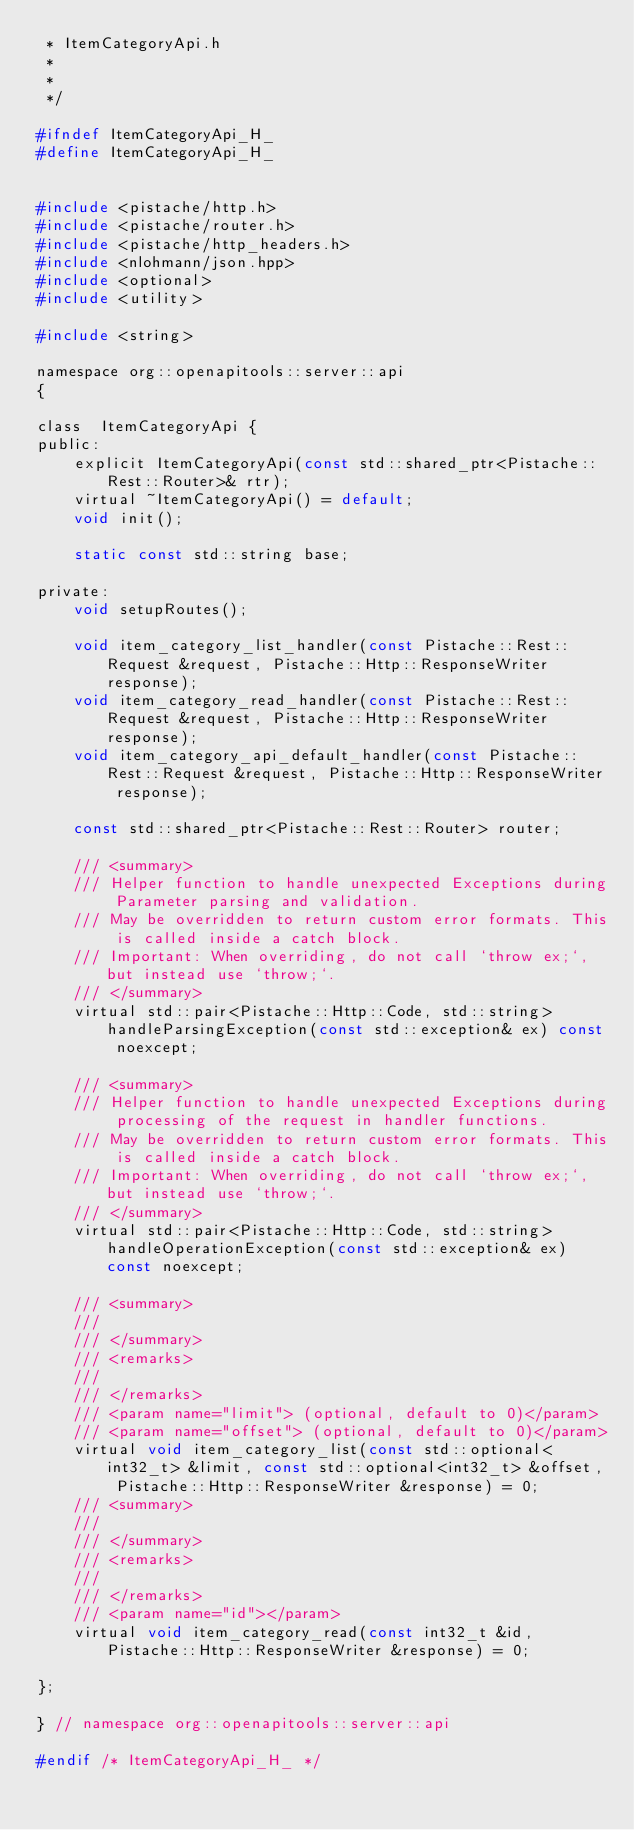<code> <loc_0><loc_0><loc_500><loc_500><_C_> * ItemCategoryApi.h
 *
 * 
 */

#ifndef ItemCategoryApi_H_
#define ItemCategoryApi_H_


#include <pistache/http.h>
#include <pistache/router.h>
#include <pistache/http_headers.h>
#include <nlohmann/json.hpp>
#include <optional>
#include <utility>

#include <string>

namespace org::openapitools::server::api
{

class  ItemCategoryApi {
public:
    explicit ItemCategoryApi(const std::shared_ptr<Pistache::Rest::Router>& rtr);
    virtual ~ItemCategoryApi() = default;
    void init();

    static const std::string base;

private:
    void setupRoutes();

    void item_category_list_handler(const Pistache::Rest::Request &request, Pistache::Http::ResponseWriter response);
    void item_category_read_handler(const Pistache::Rest::Request &request, Pistache::Http::ResponseWriter response);
    void item_category_api_default_handler(const Pistache::Rest::Request &request, Pistache::Http::ResponseWriter response);

    const std::shared_ptr<Pistache::Rest::Router> router;

    /// <summary>
    /// Helper function to handle unexpected Exceptions during Parameter parsing and validation.
    /// May be overridden to return custom error formats. This is called inside a catch block.
    /// Important: When overriding, do not call `throw ex;`, but instead use `throw;`.
    /// </summary>
    virtual std::pair<Pistache::Http::Code, std::string> handleParsingException(const std::exception& ex) const noexcept;

    /// <summary>
    /// Helper function to handle unexpected Exceptions during processing of the request in handler functions.
    /// May be overridden to return custom error formats. This is called inside a catch block.
    /// Important: When overriding, do not call `throw ex;`, but instead use `throw;`.
    /// </summary>
    virtual std::pair<Pistache::Http::Code, std::string> handleOperationException(const std::exception& ex) const noexcept;

    /// <summary>
    /// 
    /// </summary>
    /// <remarks>
    /// 
    /// </remarks>
    /// <param name="limit"> (optional, default to 0)</param>
    /// <param name="offset"> (optional, default to 0)</param>
    virtual void item_category_list(const std::optional<int32_t> &limit, const std::optional<int32_t> &offset, Pistache::Http::ResponseWriter &response) = 0;
    /// <summary>
    /// 
    /// </summary>
    /// <remarks>
    /// 
    /// </remarks>
    /// <param name="id"></param>
    virtual void item_category_read(const int32_t &id, Pistache::Http::ResponseWriter &response) = 0;

};

} // namespace org::openapitools::server::api

#endif /* ItemCategoryApi_H_ */

</code> 